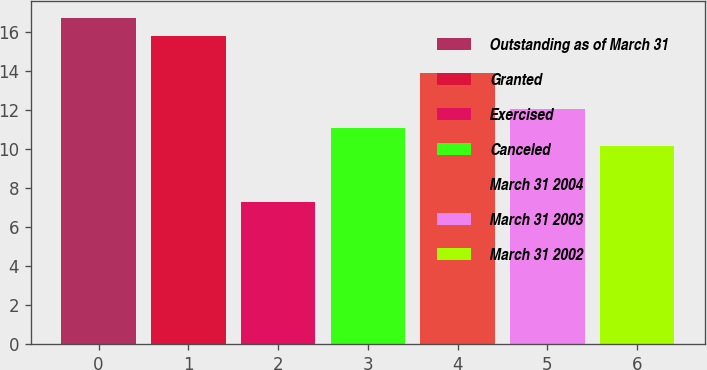Convert chart to OTSL. <chart><loc_0><loc_0><loc_500><loc_500><bar_chart><fcel>Outstanding as of March 31<fcel>Granted<fcel>Exercised<fcel>Canceled<fcel>March 31 2004<fcel>March 31 2003<fcel>March 31 2002<nl><fcel>16.74<fcel>15.8<fcel>7.28<fcel>11.1<fcel>13.92<fcel>12.04<fcel>10.16<nl></chart> 